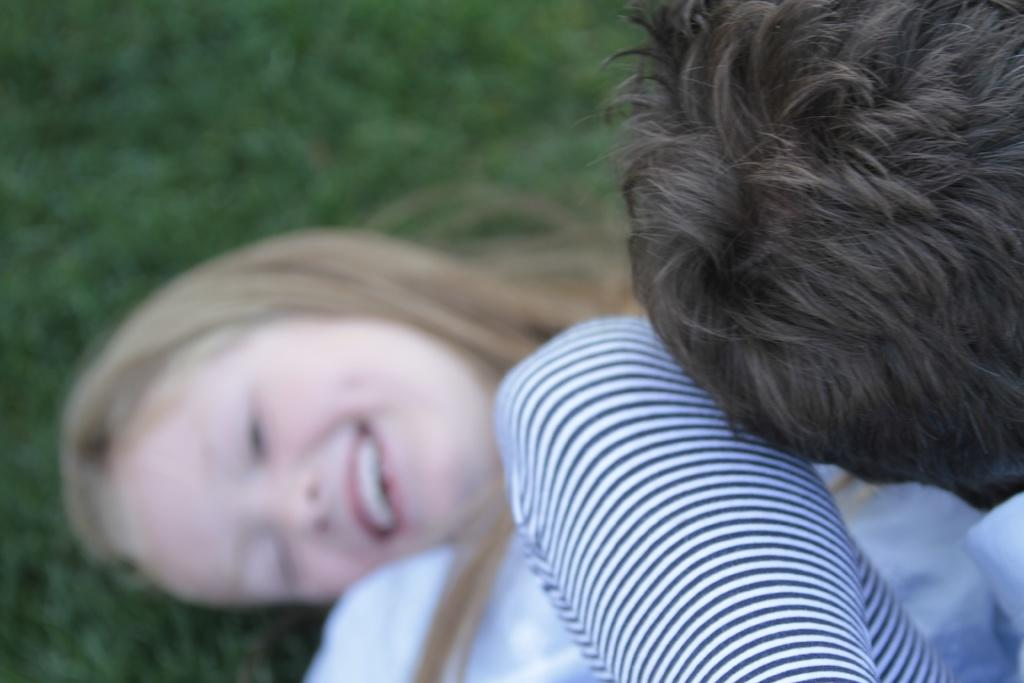What is the girl in the image doing? The girl is lying on the ground in the image. What type of surface is the girl lying on? There is grass visible in the image, so the girl is lying on the grass. Whose head is present in the image? The head of the girl lying on the ground is present in the image. Where is the glove located in the image? There is no glove present in the image. What type of market is visible in the image? There is no market present in the image. 